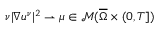<formula> <loc_0><loc_0><loc_500><loc_500>\nu | \nabla u ^ { \nu } | ^ { 2 } \rightharpoonup \mu \in \mathcal { M } ( \overline { \Omega } \times ( 0 , T ] )</formula> 